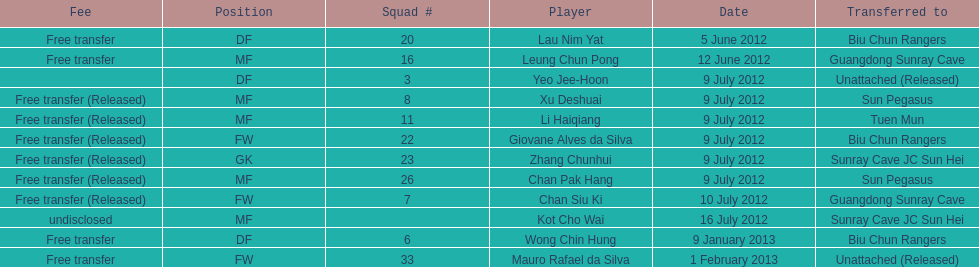How many consecutive players were released on july 9? 6. 